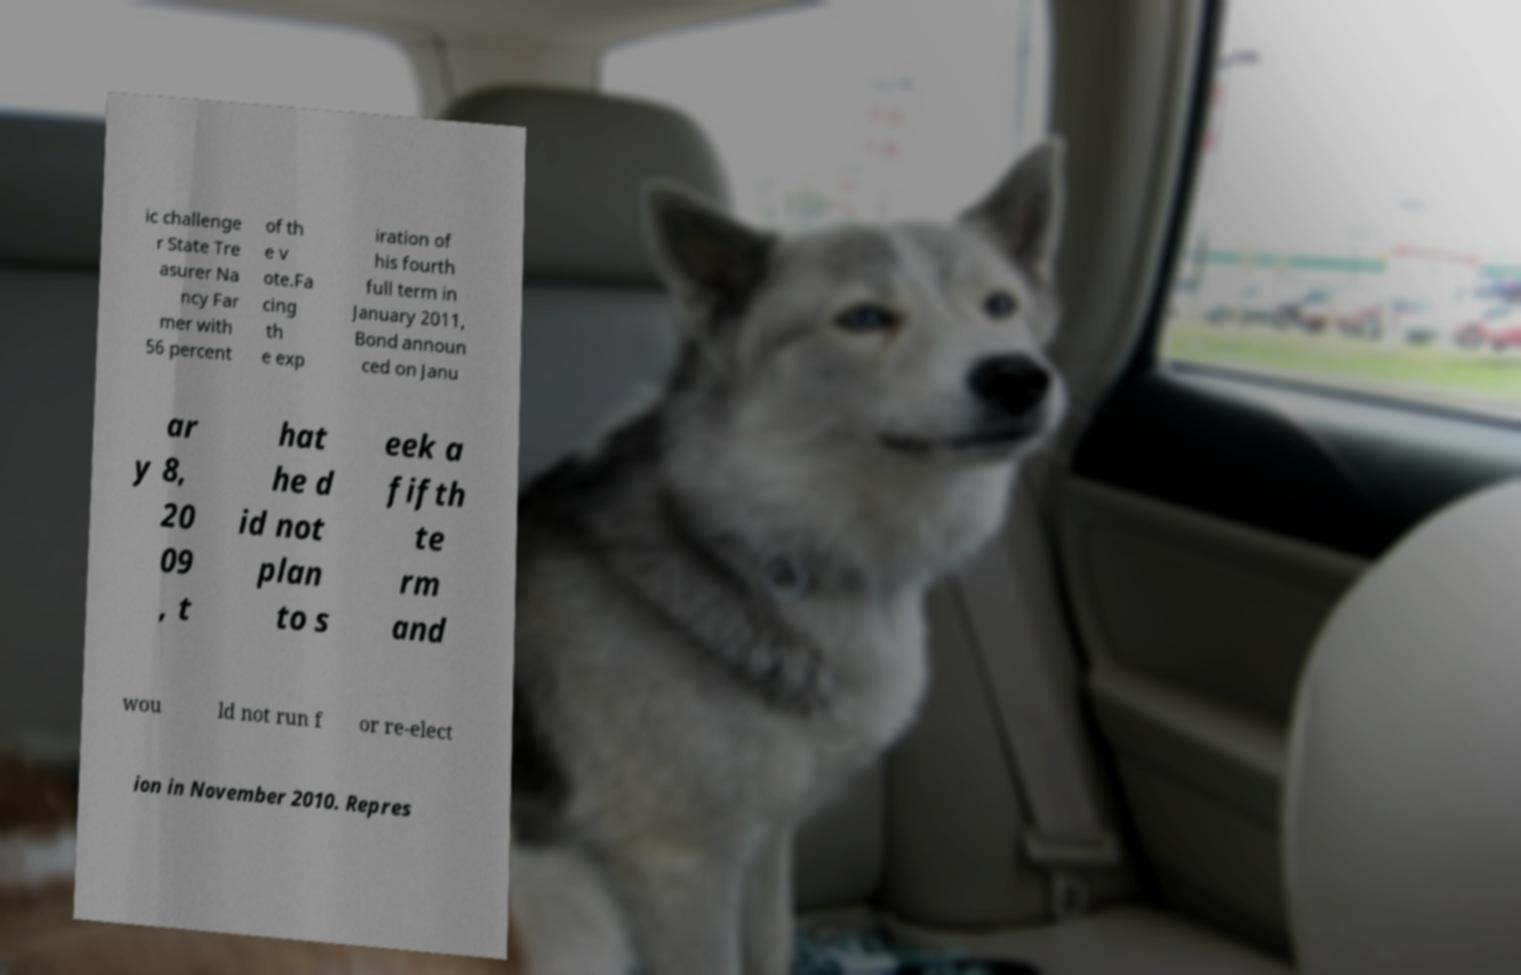Could you assist in decoding the text presented in this image and type it out clearly? ic challenge r State Tre asurer Na ncy Far mer with 56 percent of th e v ote.Fa cing th e exp iration of his fourth full term in January 2011, Bond announ ced on Janu ar y 8, 20 09 , t hat he d id not plan to s eek a fifth te rm and wou ld not run f or re-elect ion in November 2010. Repres 